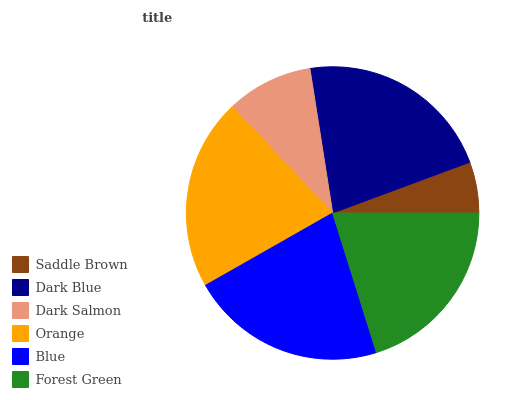Is Saddle Brown the minimum?
Answer yes or no. Yes. Is Dark Blue the maximum?
Answer yes or no. Yes. Is Dark Salmon the minimum?
Answer yes or no. No. Is Dark Salmon the maximum?
Answer yes or no. No. Is Dark Blue greater than Dark Salmon?
Answer yes or no. Yes. Is Dark Salmon less than Dark Blue?
Answer yes or no. Yes. Is Dark Salmon greater than Dark Blue?
Answer yes or no. No. Is Dark Blue less than Dark Salmon?
Answer yes or no. No. Is Orange the high median?
Answer yes or no. Yes. Is Forest Green the low median?
Answer yes or no. Yes. Is Forest Green the high median?
Answer yes or no. No. Is Dark Blue the low median?
Answer yes or no. No. 